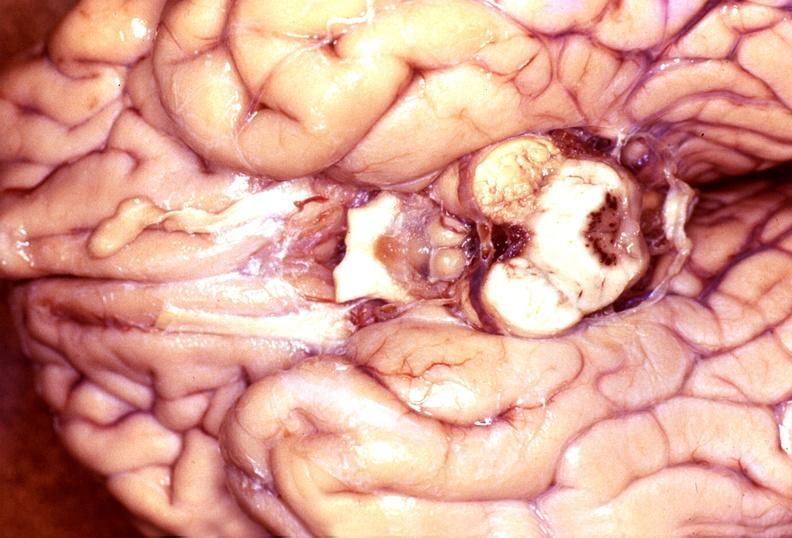what is present?
Answer the question using a single word or phrase. Nervous 